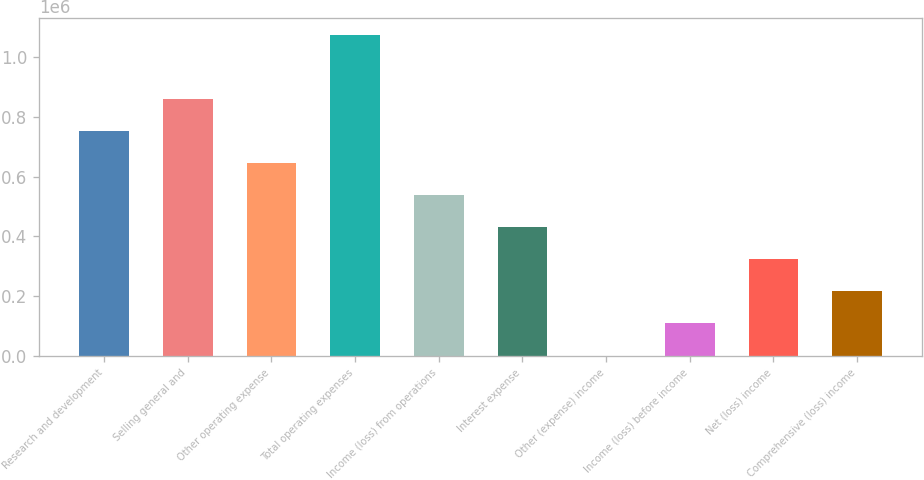Convert chart to OTSL. <chart><loc_0><loc_0><loc_500><loc_500><bar_chart><fcel>Research and development<fcel>Selling general and<fcel>Other operating expense<fcel>Total operating expenses<fcel>Income (loss) from operations<fcel>Interest expense<fcel>Other (expense) income<fcel>Income (loss) before income<fcel>Net (loss) income<fcel>Comprehensive (loss) income<nl><fcel>753861<fcel>861468<fcel>646253<fcel>1.07668e+06<fcel>538645<fcel>431037<fcel>606<fcel>108214<fcel>323429<fcel>215822<nl></chart> 